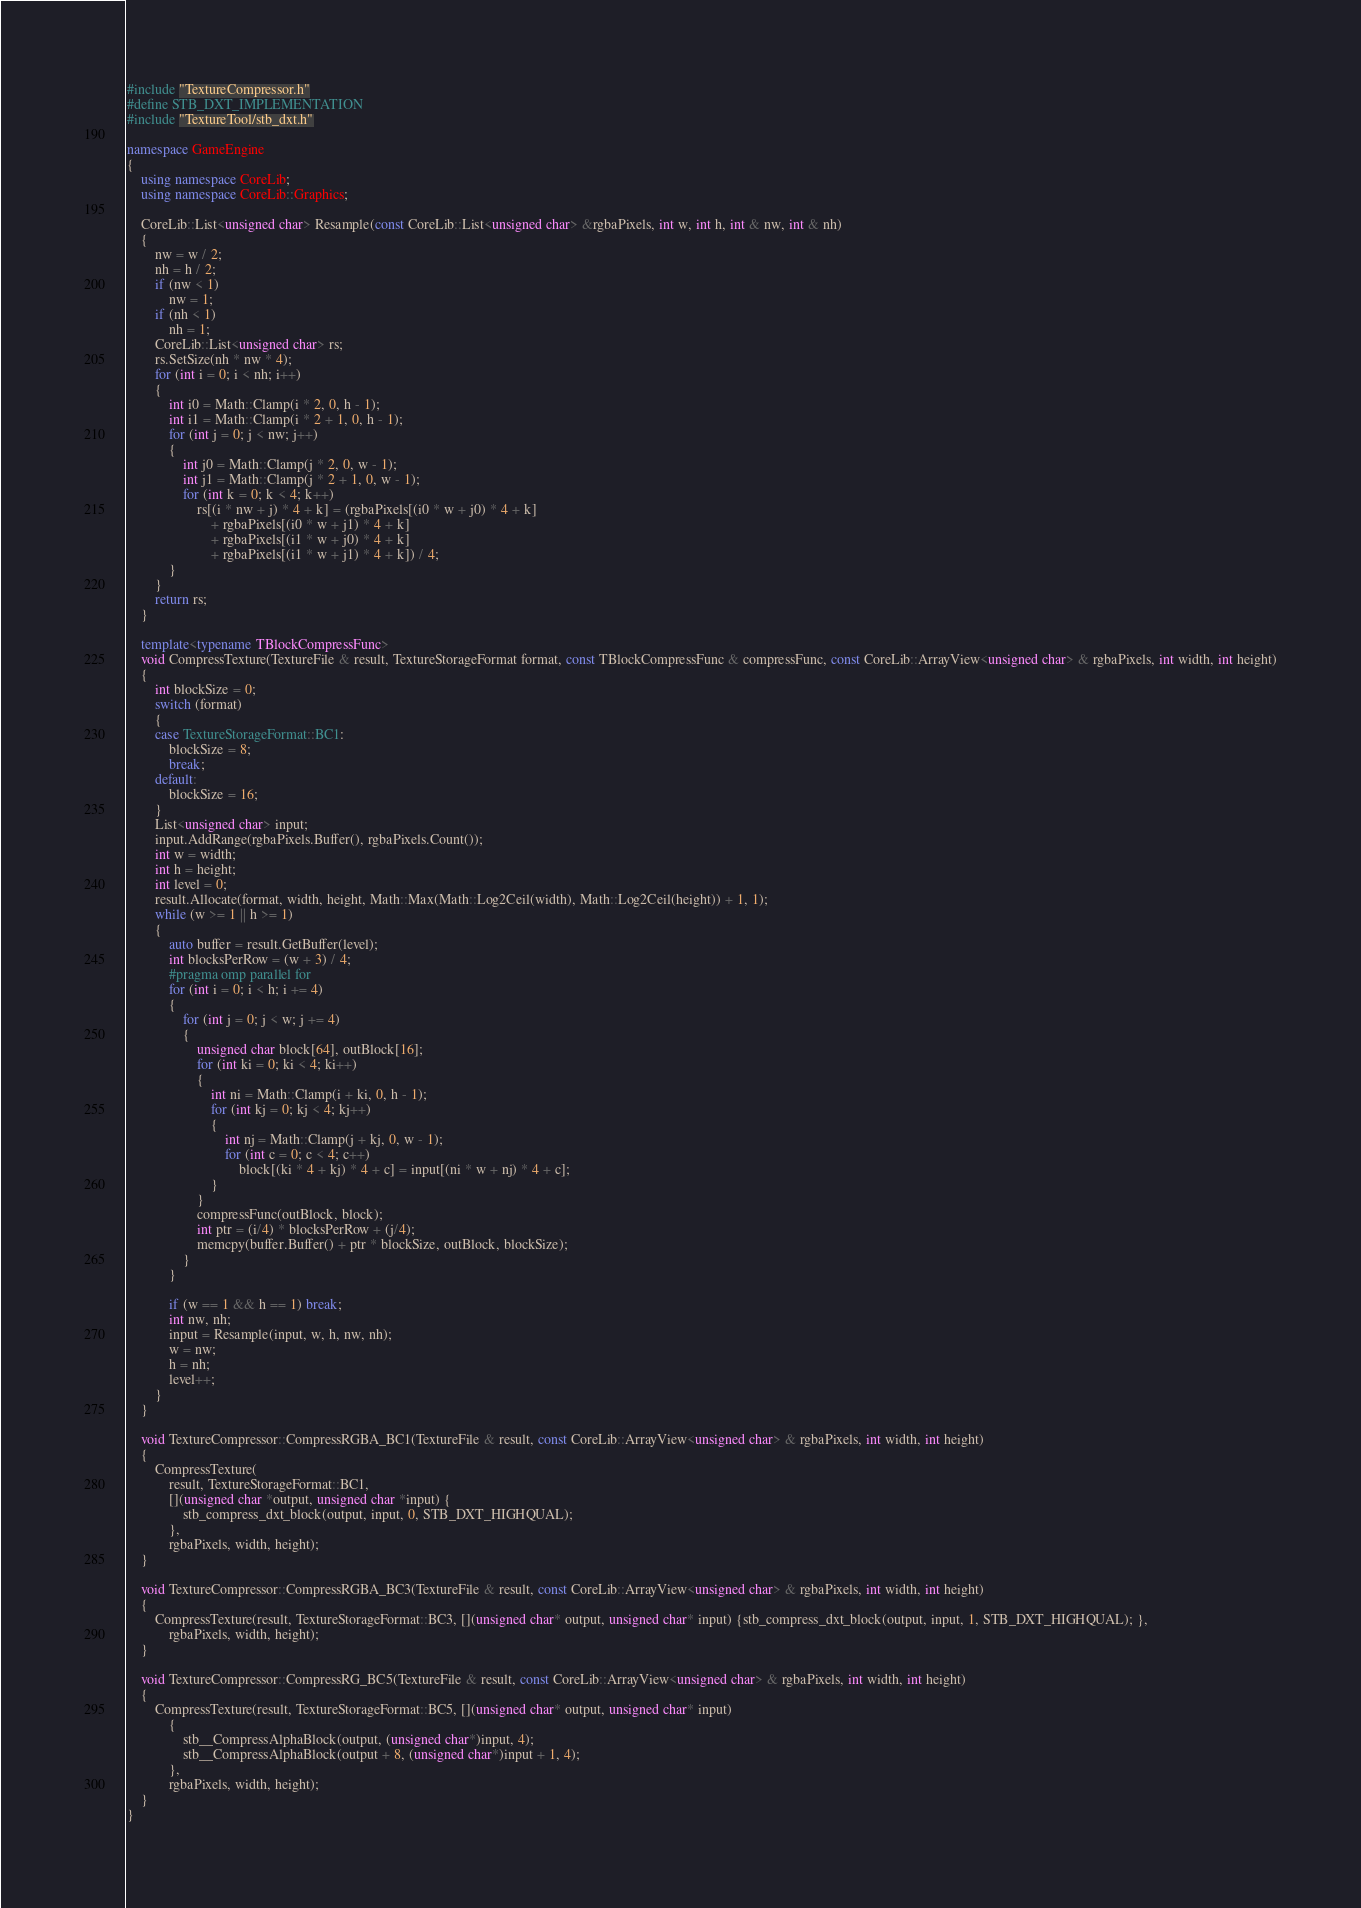<code> <loc_0><loc_0><loc_500><loc_500><_C++_>#include "TextureCompressor.h"
#define STB_DXT_IMPLEMENTATION
#include "TextureTool/stb_dxt.h"

namespace GameEngine
{
	using namespace CoreLib;
	using namespace CoreLib::Graphics;

	CoreLib::List<unsigned char> Resample(const CoreLib::List<unsigned char> &rgbaPixels, int w, int h, int & nw, int & nh)
	{
		nw = w / 2;
		nh = h / 2;
		if (nw < 1)
			nw = 1;
		if (nh < 1)
			nh = 1;
		CoreLib::List<unsigned char> rs;
		rs.SetSize(nh * nw * 4);
		for (int i = 0; i < nh; i++)
		{
			int i0 = Math::Clamp(i * 2, 0, h - 1);
			int i1 = Math::Clamp(i * 2 + 1, 0, h - 1);
			for (int j = 0; j < nw; j++)
			{
				int j0 = Math::Clamp(j * 2, 0, w - 1);
				int j1 = Math::Clamp(j * 2 + 1, 0, w - 1);
				for (int k = 0; k < 4; k++)
					rs[(i * nw + j) * 4 + k] = (rgbaPixels[(i0 * w + j0) * 4 + k] 
						+ rgbaPixels[(i0 * w + j1) * 4 + k] 
						+ rgbaPixels[(i1 * w + j0) * 4 + k] 
						+ rgbaPixels[(i1 * w + j1) * 4 + k]) / 4;
			}
		}
		return rs;
	}

    template<typename TBlockCompressFunc>
    void CompressTexture(TextureFile & result, TextureStorageFormat format, const TBlockCompressFunc & compressFunc, const CoreLib::ArrayView<unsigned char> & rgbaPixels, int width, int height)
    {
        int blockSize = 0;
        switch (format)
        {
        case TextureStorageFormat::BC1:
            blockSize = 8;
            break;
        default:
            blockSize = 16;
        }
        List<unsigned char> input;
        input.AddRange(rgbaPixels.Buffer(), rgbaPixels.Count());
        int w = width;
        int h = height;
        int level = 0;
        result.Allocate(format, width, height, Math::Max(Math::Log2Ceil(width), Math::Log2Ceil(height)) + 1, 1);
        while (w >= 1 || h >= 1)
        {
            auto buffer = result.GetBuffer(level);
            int blocksPerRow = (w + 3) / 4;
            #pragma omp parallel for
            for (int i = 0; i < h; i += 4)
            {
                for (int j = 0; j < w; j += 4)
                {
                    unsigned char block[64], outBlock[16];
                    for (int ki = 0; ki < 4; ki++)
                    {
                        int ni = Math::Clamp(i + ki, 0, h - 1);
                        for (int kj = 0; kj < 4; kj++)
                        {
                            int nj = Math::Clamp(j + kj, 0, w - 1);
                            for (int c = 0; c < 4; c++)
                                block[(ki * 4 + kj) * 4 + c] = input[(ni * w + nj) * 4 + c];
                        }
                    }
                    compressFunc(outBlock, block);
                    int ptr = (i/4) * blocksPerRow + (j/4);
                    memcpy(buffer.Buffer() + ptr * blockSize, outBlock, blockSize);
                }
            }

            if (w == 1 && h == 1) break;
            int nw, nh;
            input = Resample(input, w, h, nw, nh);
            w = nw;
            h = nh;
            level++;
        }
    }

	void TextureCompressor::CompressRGBA_BC1(TextureFile & result, const CoreLib::ArrayView<unsigned char> & rgbaPixels, int width, int height)
	{
        CompressTexture(
            result, TextureStorageFormat::BC1,
            [](unsigned char *output, unsigned char *input) {
                stb_compress_dxt_block(output, input, 0, STB_DXT_HIGHQUAL);
            },
            rgbaPixels, width, height);
	}

	void TextureCompressor::CompressRGBA_BC3(TextureFile & result, const CoreLib::ArrayView<unsigned char> & rgbaPixels, int width, int height)
	{
        CompressTexture(result, TextureStorageFormat::BC3, [](unsigned char* output, unsigned char* input) {stb_compress_dxt_block(output, input, 1, STB_DXT_HIGHQUAL); },
            rgbaPixels, width, height);
	}

	void TextureCompressor::CompressRG_BC5(TextureFile & result, const CoreLib::ArrayView<unsigned char> & rgbaPixels, int width, int height)
	{
        CompressTexture(result, TextureStorageFormat::BC5, [](unsigned char* output, unsigned char* input)
            {
                stb__CompressAlphaBlock(output, (unsigned char*)input, 4);
                stb__CompressAlphaBlock(output + 8, (unsigned char*)input + 1, 4);
            },
            rgbaPixels, width, height);
	}
}

</code> 